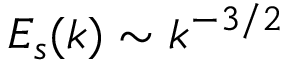Convert formula to latex. <formula><loc_0><loc_0><loc_500><loc_500>E _ { s } ( k ) \sim k ^ { - 3 / 2 }</formula> 